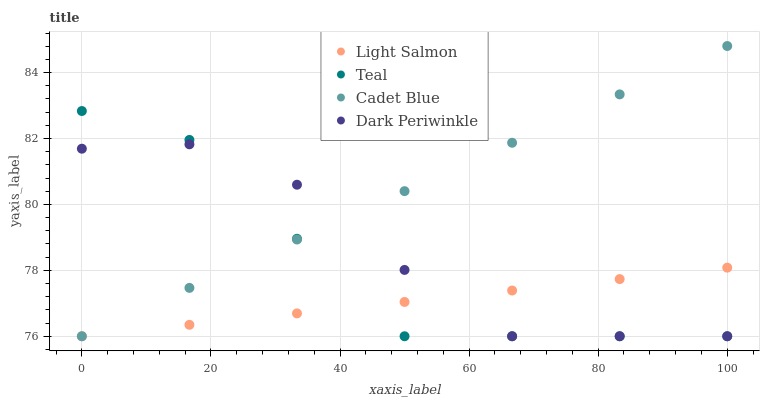Does Light Salmon have the minimum area under the curve?
Answer yes or no. Yes. Does Cadet Blue have the maximum area under the curve?
Answer yes or no. Yes. Does Dark Periwinkle have the minimum area under the curve?
Answer yes or no. No. Does Dark Periwinkle have the maximum area under the curve?
Answer yes or no. No. Is Light Salmon the smoothest?
Answer yes or no. Yes. Is Dark Periwinkle the roughest?
Answer yes or no. Yes. Is Cadet Blue the smoothest?
Answer yes or no. No. Is Cadet Blue the roughest?
Answer yes or no. No. Does Light Salmon have the lowest value?
Answer yes or no. Yes. Does Cadet Blue have the highest value?
Answer yes or no. Yes. Does Dark Periwinkle have the highest value?
Answer yes or no. No. Does Teal intersect Cadet Blue?
Answer yes or no. Yes. Is Teal less than Cadet Blue?
Answer yes or no. No. Is Teal greater than Cadet Blue?
Answer yes or no. No. 